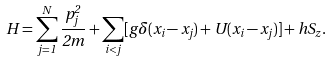<formula> <loc_0><loc_0><loc_500><loc_500>H = \sum _ { j = 1 } ^ { N } \frac { p _ { j } ^ { 2 } } { 2 m } + \sum _ { i < j } [ g \delta ( x _ { i } - x _ { j } ) + U ( x _ { i } - x _ { j } ) ] + h S _ { z } .</formula> 